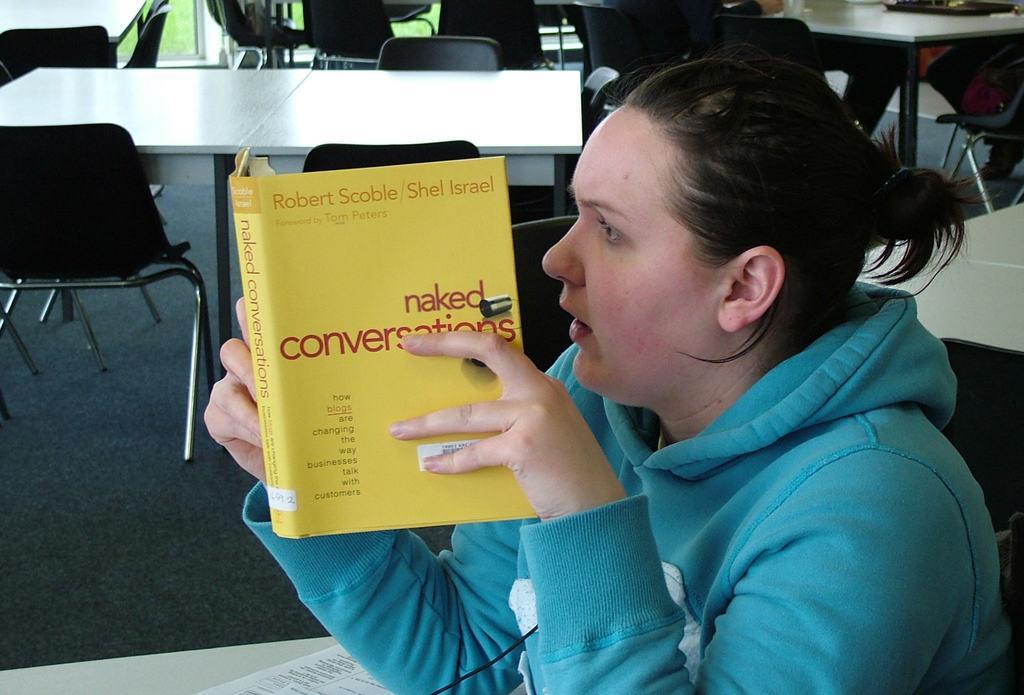Please provide a concise description of this image. In the picture we can see a woman sitting on the chair near the table and looking into the book, holding it and beside her we can see some tables and chairs. 